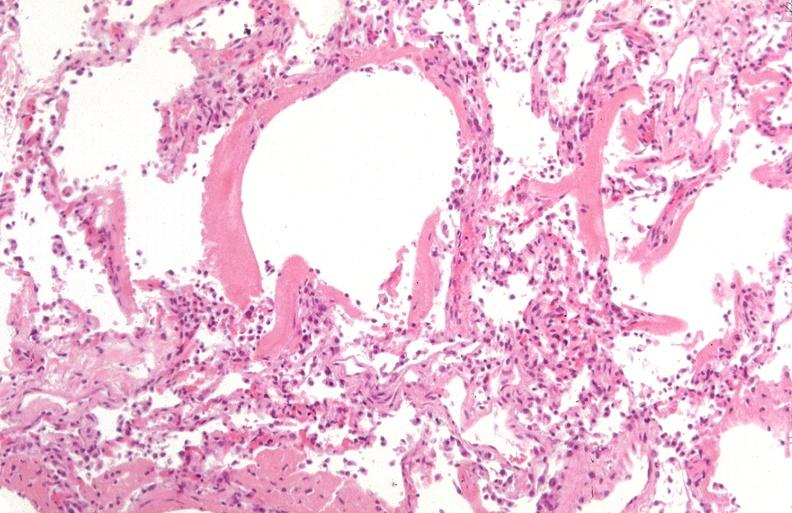where is this?
Answer the question using a single word or phrase. Lung 